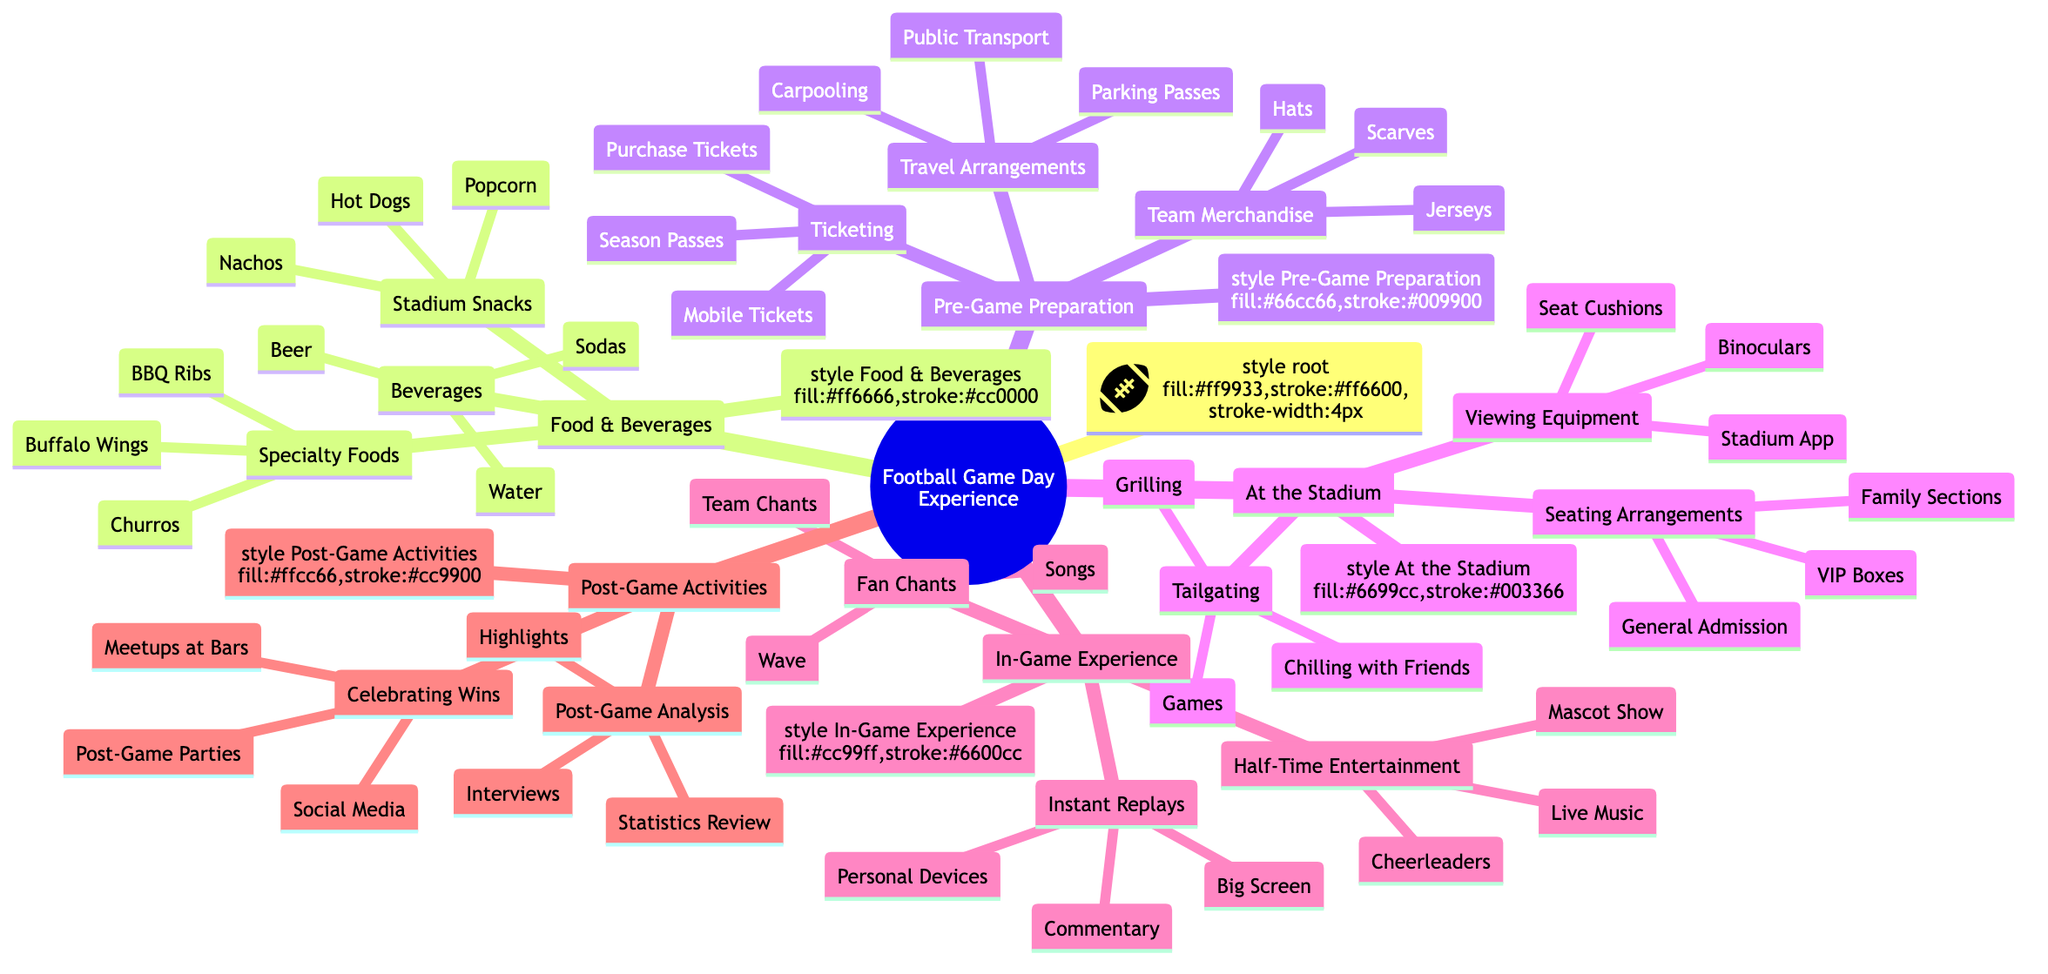What are three types of stadium snacks? The diagram lists "Stadium Snacks" under "Food & Beverages." It provides three examples: Hot Dogs, Nachos, and Popcorn as specific types of snacks available at the stadium.
Answer: Hot Dogs, Nachos, Popcorn How many main categories are there in the Football Game Day Experience? The diagram shows five main categories branching from the root node: Pre-Game Preparation, At the Stadium, Food & Beverages, In-Game Experience, and Post-Game Activities. Counting these gives us five main categories.
Answer: 5 What activity is listed under "At the Stadium" that involves cooking? The diagram mentions "Grilling" as an activity under "Tailgating," which is part of "At the Stadium." It highlights the cooking aspect related to food preparation before the game starts.
Answer: Grilling What does the "Half-Time Entertainment" section include? According to the diagram, "Half-Time Entertainment" lists three activities: Cheerleaders, Mascot Show, and Live Music, which all occur during the halftime break of the game.
Answer: Cheerleaders, Mascot Show, Live Music What is one option for travel arrangements? The diagram under "Travel Arrangements" presents several options, including Carpooling, Public Transport, and Parking Passes. Selecting any of these would answer the question.
Answer: Carpooling What is the relationship between "Seating Arrangements" and "Viewing Equipment"? "Seating Arrangements" and "Viewing Equipment" are both categories within the "At the Stadium" section, relating to different aspects of the in-stadium experience—one focusing on where fans sit and the other on tools to enhance the viewing experience.
Answer: Both are under "At the Stadium" What can fans do after a game finishes? The "Post-Game Activities" section includes actions like "Post-Game Analysis" which covers Interviews, Statistics Review, and Highlights, and "Celebrating Wins" which involves Post-Game Parties. Thus, fans can engage in both activities after a game.
Answer: Post-Game Analysis, Celebrating Wins Which food category includes BBQ Ribs? BBQ Ribs are listed under "Specialty Foods," which is a subsection of "Food & Beverages." This categorization identifies BBQ Ribs as a type of specialty item served on game day.
Answer: Specialty Foods How many options are there under "Ticketing"? The diagram presents three options under the "Ticketing" subsection: Purchase Tickets, Mobile Tickets, and Season Passes. Therefore, the number of ticketing options is three.
Answer: 3 